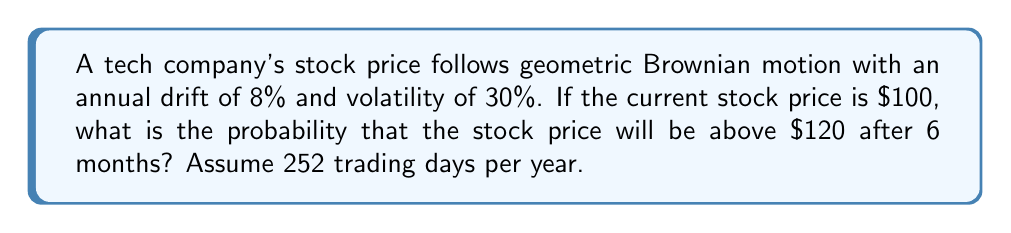Provide a solution to this math problem. Let's approach this step-by-step using the properties of geometric Brownian motion:

1) For a stock price $S_t$ following geometric Brownian motion:

   $$\frac{dS_t}{S_t} = \mu dt + \sigma dW_t$$

   where $\mu$ is the drift, $\sigma$ is the volatility, and $W_t$ is a Wiener process.

2) The solution to this SDE gives the log-normal distribution of stock prices:

   $$\ln(S_t/S_0) \sim N((\mu - \frac{\sigma^2}{2})t, \sigma^2t)$$

3) Given:
   - Initial price $S_0 = 100$
   - Target price $S_t = 120$
   - Time $t = 0.5$ years (6 months)
   - Annual drift $\mu = 0.08$
   - Annual volatility $\sigma = 0.30$

4) We need to find $P(S_t > 120)$, which is equivalent to $P(\ln(S_t/S_0) > \ln(120/100))$

5) Calculate the mean and standard deviation of $\ln(S_t/S_0)$:
   
   Mean: $(\mu - \frac{\sigma^2}{2})t = (0.08 - \frac{0.30^2}{2}) * 0.5 = 0.01375$
   
   Standard deviation: $\sigma\sqrt{t} = 0.30\sqrt{0.5} = 0.212132$

6) Standardize the log-return:

   $$Z = \frac{\ln(120/100) - 0.01375}{0.212132} = 0.8240$$

7) The probability we're looking for is $P(Z > 0.8240)$, which is $1 - \Phi(0.8240)$, where $\Phi$ is the standard normal CDF.

8) Using a standard normal table or calculator:

   $1 - \Phi(0.8240) \approx 0.2050$

Therefore, the probability that the stock price will be above $120 after 6 months is approximately 0.2050 or 20.50%.
Answer: 0.2050 (or 20.50%) 